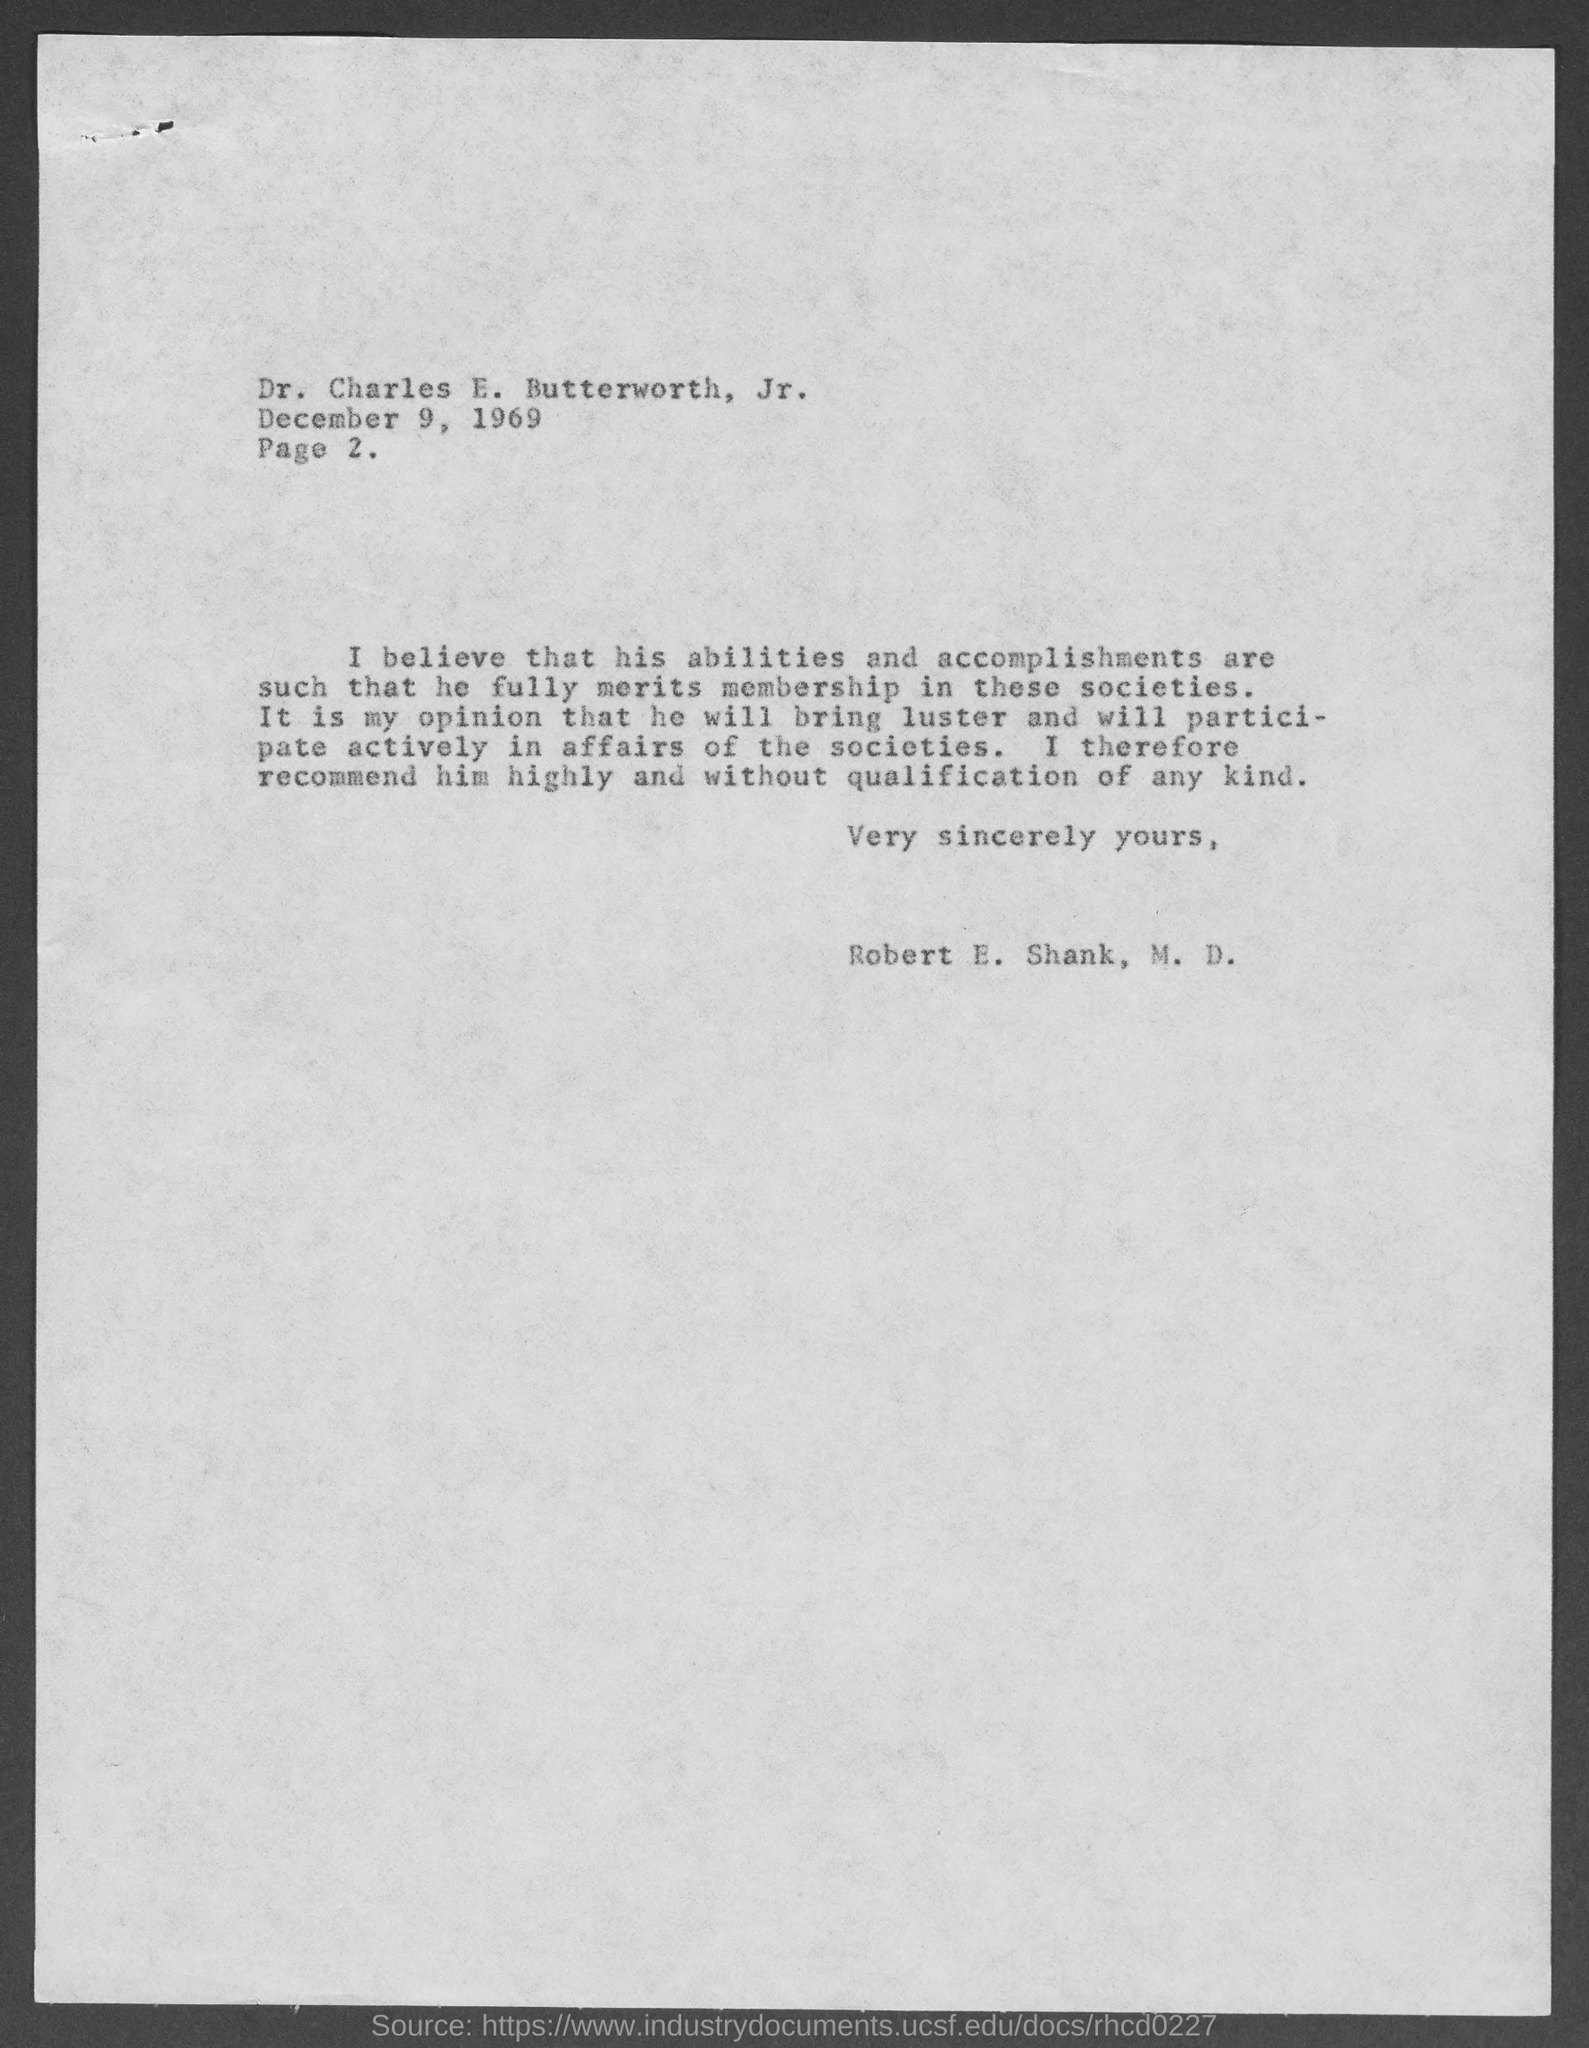What is the page number ?
Provide a succinct answer. Page 2. To whom is this letter written to?
Keep it short and to the point. Dr. Charles E. Butterworth, Jr. The letter is dated on?
Keep it short and to the point. December 9, 1969. 